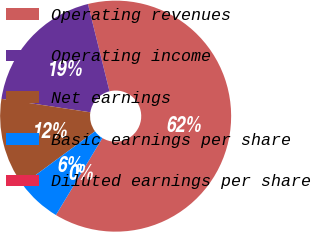Convert chart. <chart><loc_0><loc_0><loc_500><loc_500><pie_chart><fcel>Operating revenues<fcel>Operating income<fcel>Net earnings<fcel>Basic earnings per share<fcel>Diluted earnings per share<nl><fcel>62.5%<fcel>18.75%<fcel>12.5%<fcel>6.25%<fcel>0.0%<nl></chart> 